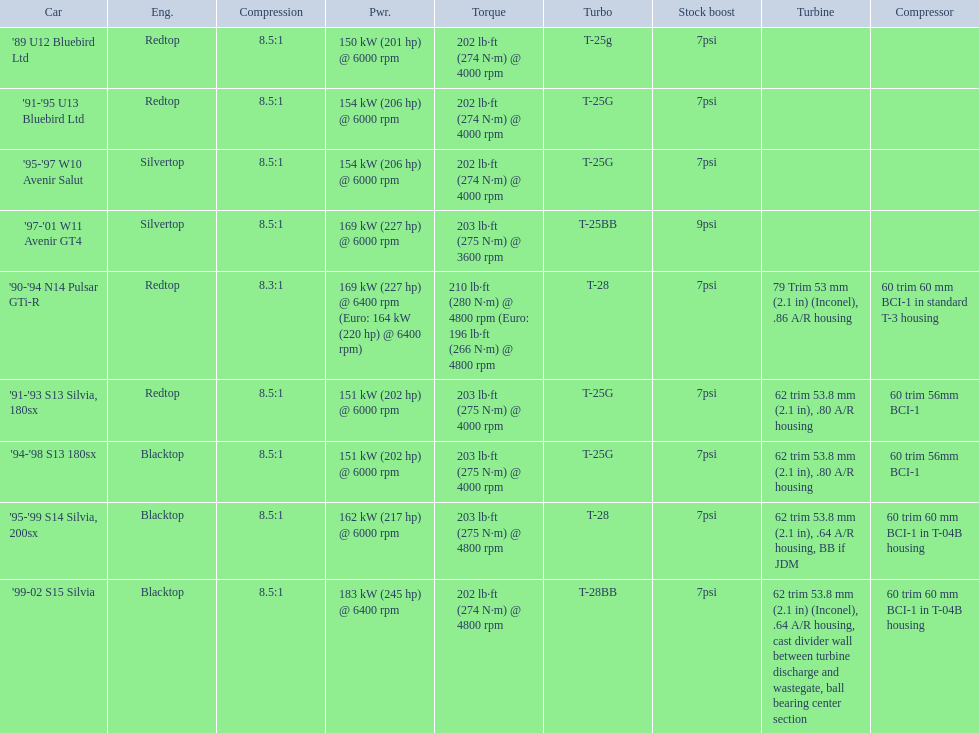How many models used the redtop engine? 4. 